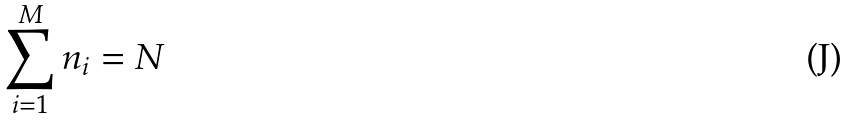Convert formula to latex. <formula><loc_0><loc_0><loc_500><loc_500>\sum _ { i = 1 } ^ { M } n _ { i } = N</formula> 